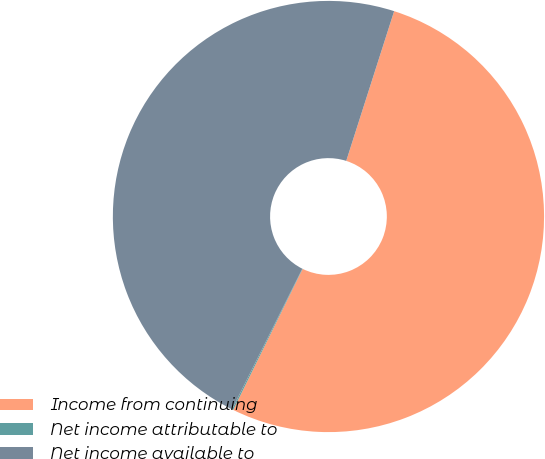<chart> <loc_0><loc_0><loc_500><loc_500><pie_chart><fcel>Income from continuing<fcel>Net income attributable to<fcel>Net income available to<nl><fcel>52.35%<fcel>0.1%<fcel>47.54%<nl></chart> 